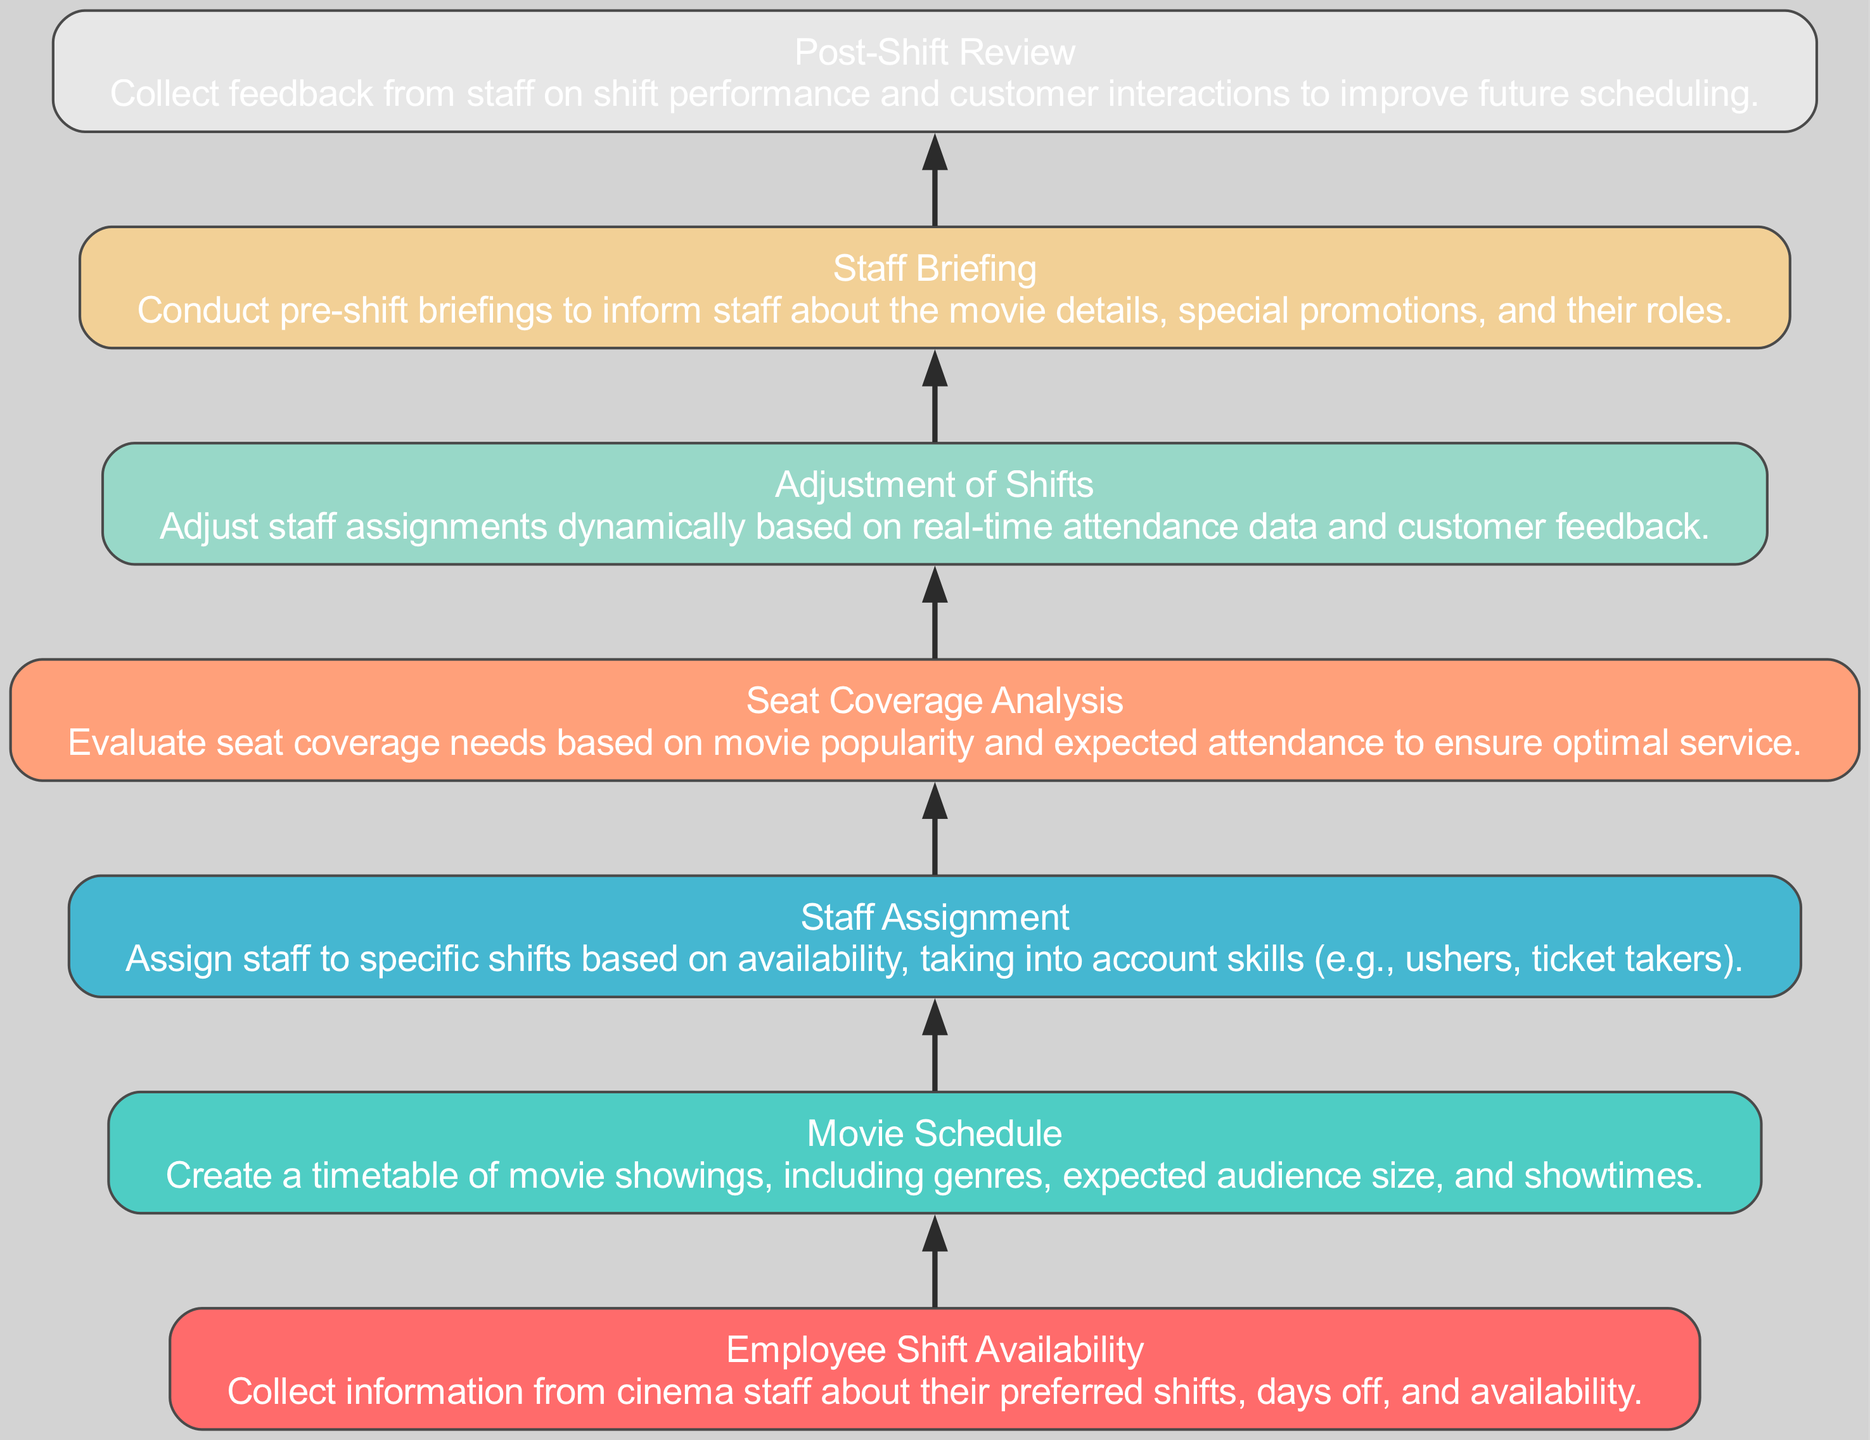What is the first step in the flow? The first step listed in the flow chart is "Employee Shift Availability," which indicates that the process starts with collecting information from staff.
Answer: Employee Shift Availability How many total nodes are in the diagram? There are 7 nodes representing different steps in the staff scheduling process, starting from shift availability to post-shift review.
Answer: 7 What step comes directly after "Movie Schedule"? The step that comes after "Movie Schedule" is "Staff Assignment," indicating staffing decisions follow scheduling.
Answer: Staff Assignment Which step primarily considers audience size and movie popularity? "Seat Coverage Analysis" evaluates these factors to ensure optimal service during movie showings.
Answer: Seat Coverage Analysis What action is taken after reviewing the staff assignments? The next action after "Staff Assignment" is to conduct "Seat Coverage Analysis" to evaluate the service requirements for the assigned shifts.
Answer: Seat Coverage Analysis What is the final step in the flow chart? The final step in the diagram is "Post-Shift Review," which collects feedback on shift performance.
Answer: Post-Shift Review Which node connects "Adjustment of Shifts" and "Staff Briefing"? The node "Staff Assignment" connects both "Adjustment of Shifts" and "Staff Briefing," indicating it is a central process between these steps.
Answer: Staff Assignment What is done during the "Staff Briefing"? During "Staff Briefing," staff are informed about movie details, special promotions, and their roles before the shift begins.
Answer: Inform staff about movie details What type of feedback is collected for improvement in the schedule? "Post-Shift Review" collects feedback on performance and customer interactions to enhance future scheduling processes.
Answer: Performance and customer interaction feedback 